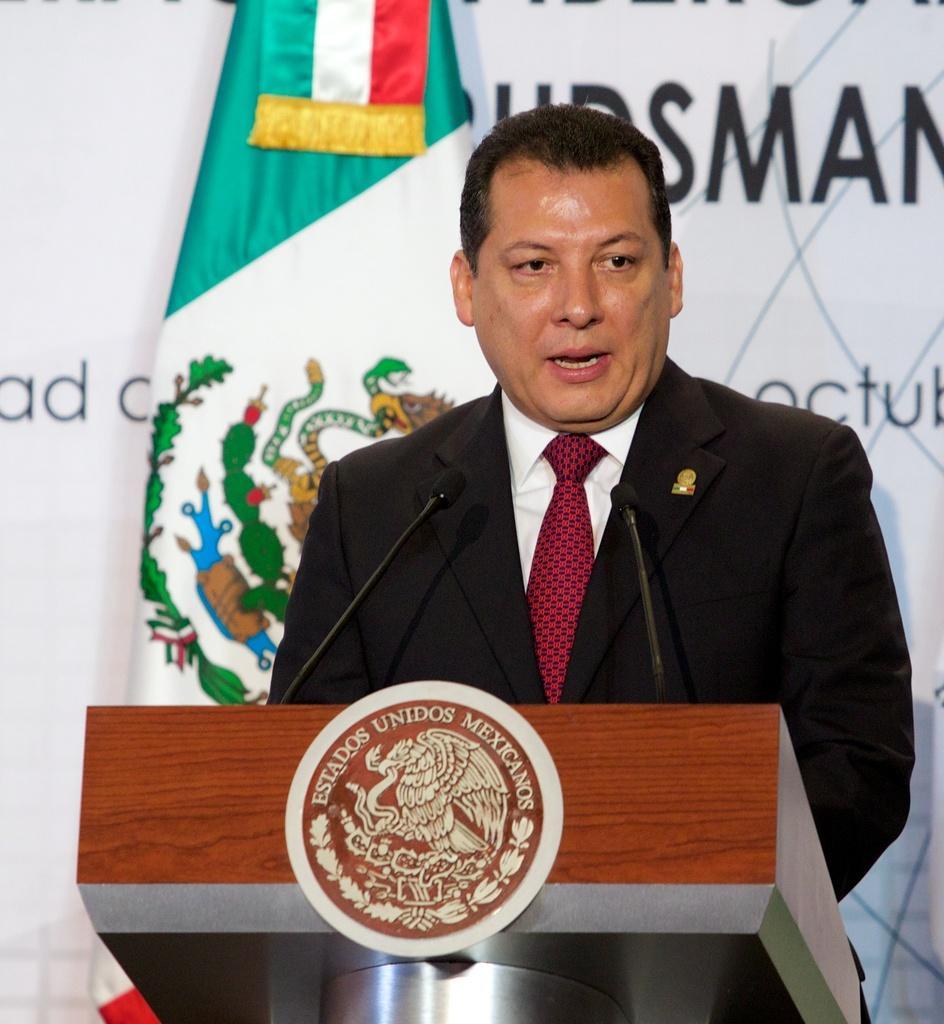In one or two sentences, can you explain what this image depicts? This is the man standing and speaking. I think this is a podium with two mikes and a logo attached to it. This looks like a flag hanging. In the background, I think this is a hoarding with the letters on it. 